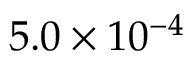Convert formula to latex. <formula><loc_0><loc_0><loc_500><loc_500>5 . 0 \times 1 0 ^ { - 4 }</formula> 